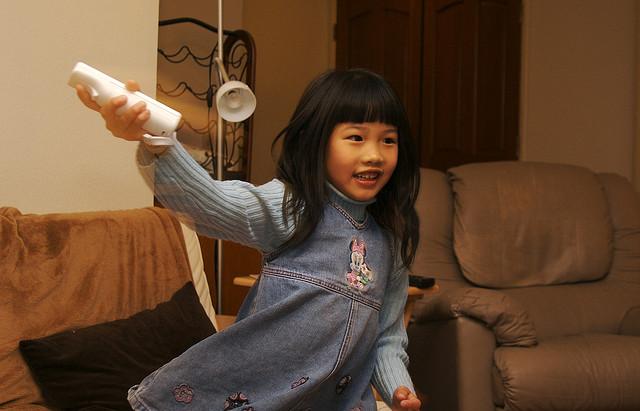How many kids?
Give a very brief answer. 1. Does the fabric have a pattern?
Concise answer only. No. What cartoon character is on the front of her dress?
Answer briefly. Minnie mouse. What color is her skirt?
Short answer required. Blue. What is the child holding?
Answer briefly. Wii controller. What color is the girl's hair?
Short answer required. Black. Does the girl have her eyes closed?
Answer briefly. No. What color is the couch?
Answer briefly. Brown. What animal is on the girls shirt?
Concise answer only. Mouse. How many people are in the photo?
Short answer required. 1. What is the baby holding?
Short answer required. Remote. Is this girl from China?
Answer briefly. Yes. What is the person holding?
Short answer required. Wii remote. What color is her shirt?
Write a very short answer. Blue. 